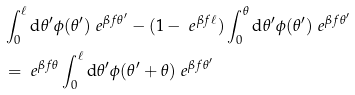Convert formula to latex. <formula><loc_0><loc_0><loc_500><loc_500>& \int _ { 0 } ^ { \ell } { \mathrm d } \theta ^ { \prime } \phi ( \theta ^ { \prime } ) \ e ^ { \beta f \theta ^ { \prime } } - ( 1 - \ e ^ { \beta f \ell } ) \int _ { 0 } ^ { \theta } { \mathrm d } \theta ^ { \prime } \phi ( \theta ^ { \prime } ) \ e ^ { \beta f \theta ^ { \prime } } \\ & = \ e ^ { \beta f \theta } \int _ { 0 } ^ { \ell } { \mathrm d } \theta ^ { \prime } \phi ( \theta ^ { \prime } + \theta ) \ e ^ { \beta f \theta ^ { \prime } }</formula> 